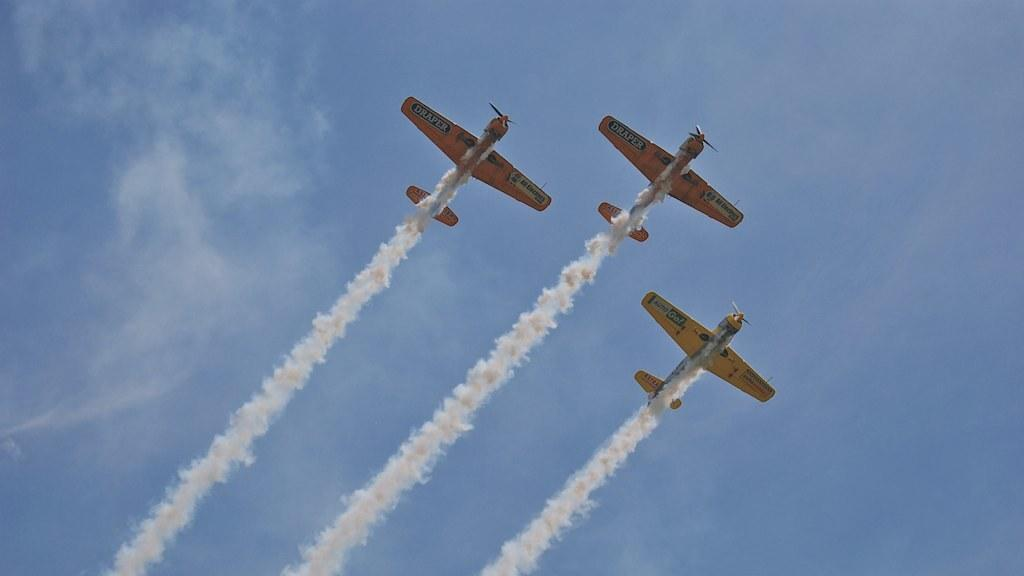What is happening in the sky in the image? There are jets flying in the sky, and smoke is coming out from them. What color is the sky in the image? The sky is blue in the image. Where is the kitten playing with a hammer in the image? There is no kitten or hammer present in the image. 